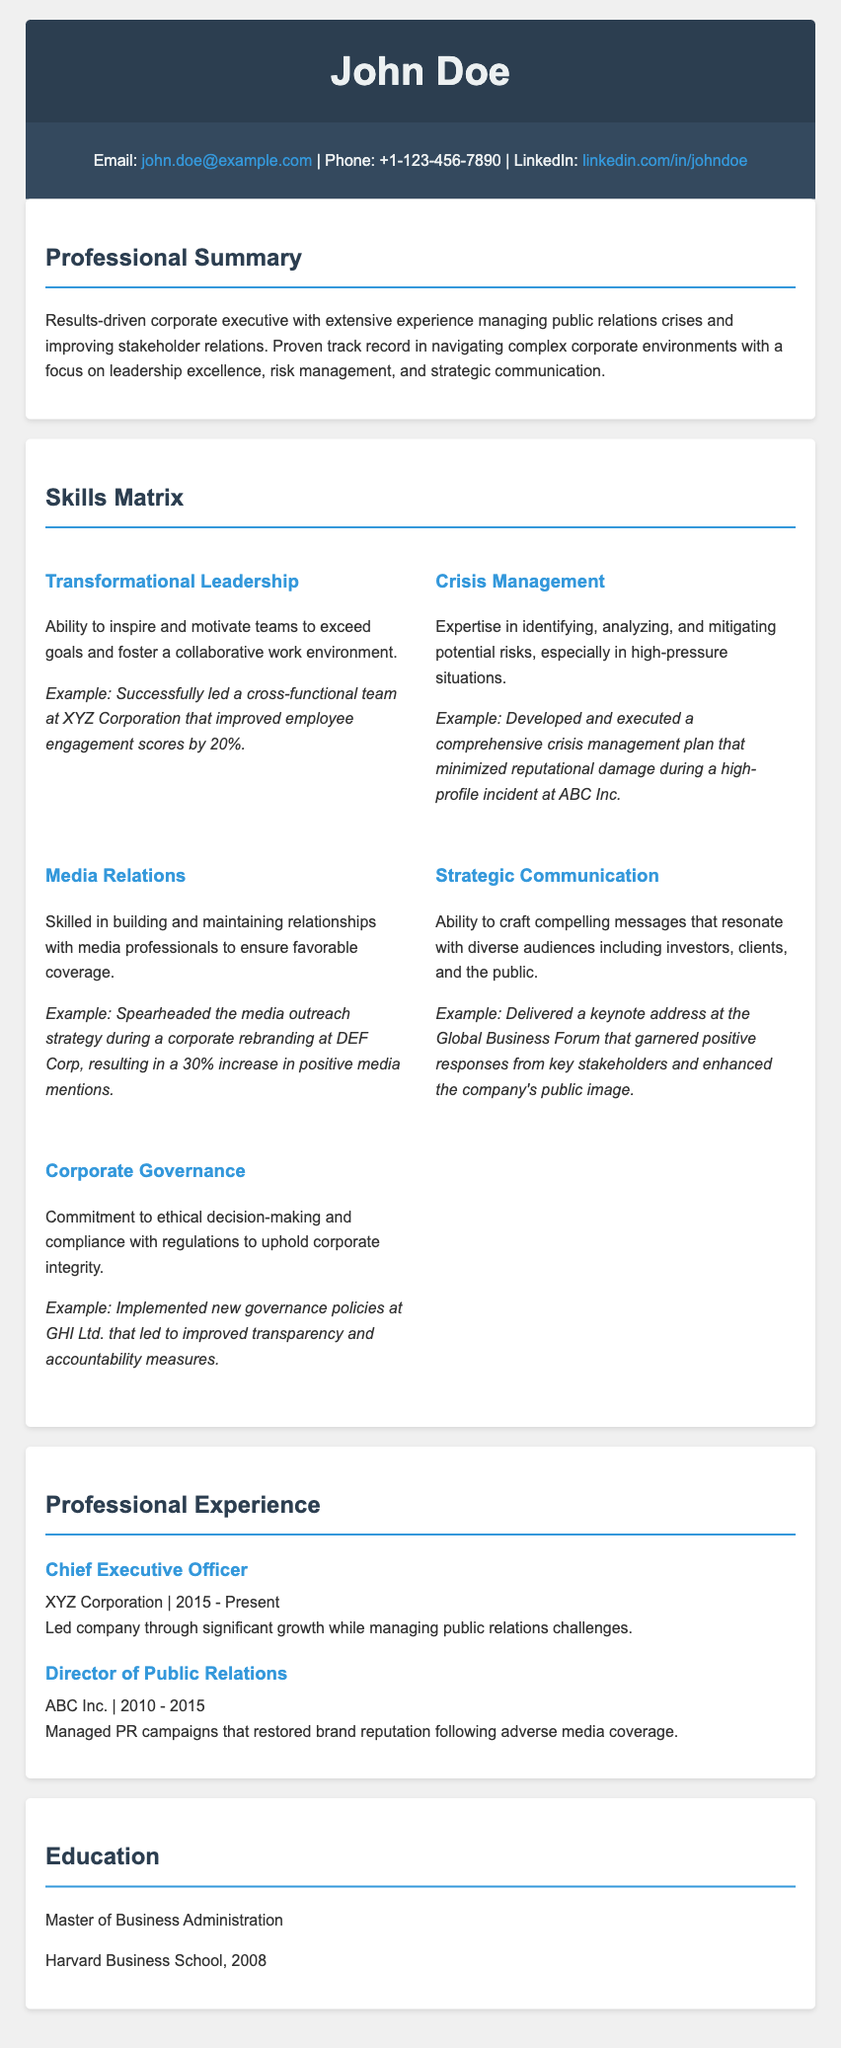what is the name of the individual? The name appears prominently in the header of the document.
Answer: John Doe what is the title of the document? The title can be found in the <title> tag of the HTML document.
Answer: John Doe - Curriculum Vitae what is John Doe's email address? The email address is provided in the contact information section.
Answer: john.doe@example.com which company did John Doe lead as CEO? The company name is mentioned under the professional experience section.
Answer: XYZ Corporation what skill is mentioned first in the Skills Matrix? The first skill listed in the matrix provides insight into John Doe's capabilities.
Answer: Transformational Leadership how long did John Doe work at ABC Inc.? The duration of employment is mentioned in the professional experience section.
Answer: 5 years what degree does John Doe hold? The education section specifies the degree earned by John Doe.
Answer: Master of Business Administration which company implemented new governance policies? The company name is mentioned in the skill regarding corporate governance.
Answer: GHI Ltd how much was the increase in positive media mentions during the rebranding at DEF Corp? The specific increase is detailed in the media relations skill description.
Answer: 30% 